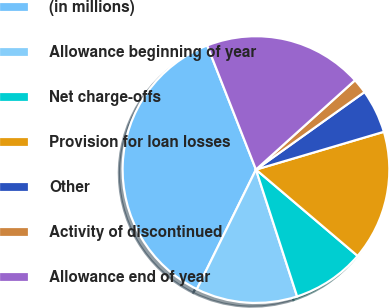Convert chart. <chart><loc_0><loc_0><loc_500><loc_500><pie_chart><fcel>(in millions)<fcel>Allowance beginning of year<fcel>Net charge-offs<fcel>Provision for loan losses<fcel>Other<fcel>Activity of discontinued<fcel>Allowance end of year<nl><fcel>36.74%<fcel>12.29%<fcel>8.8%<fcel>15.78%<fcel>5.3%<fcel>1.81%<fcel>19.28%<nl></chart> 